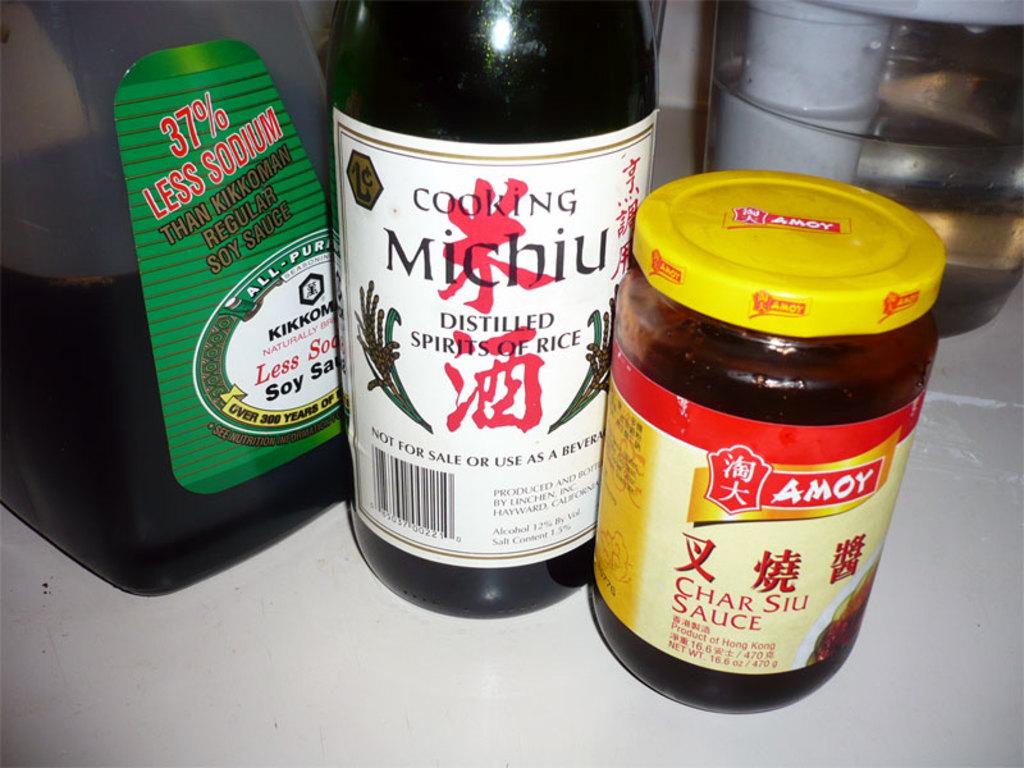What is the % of less sodium?
Give a very brief answer. 37. 